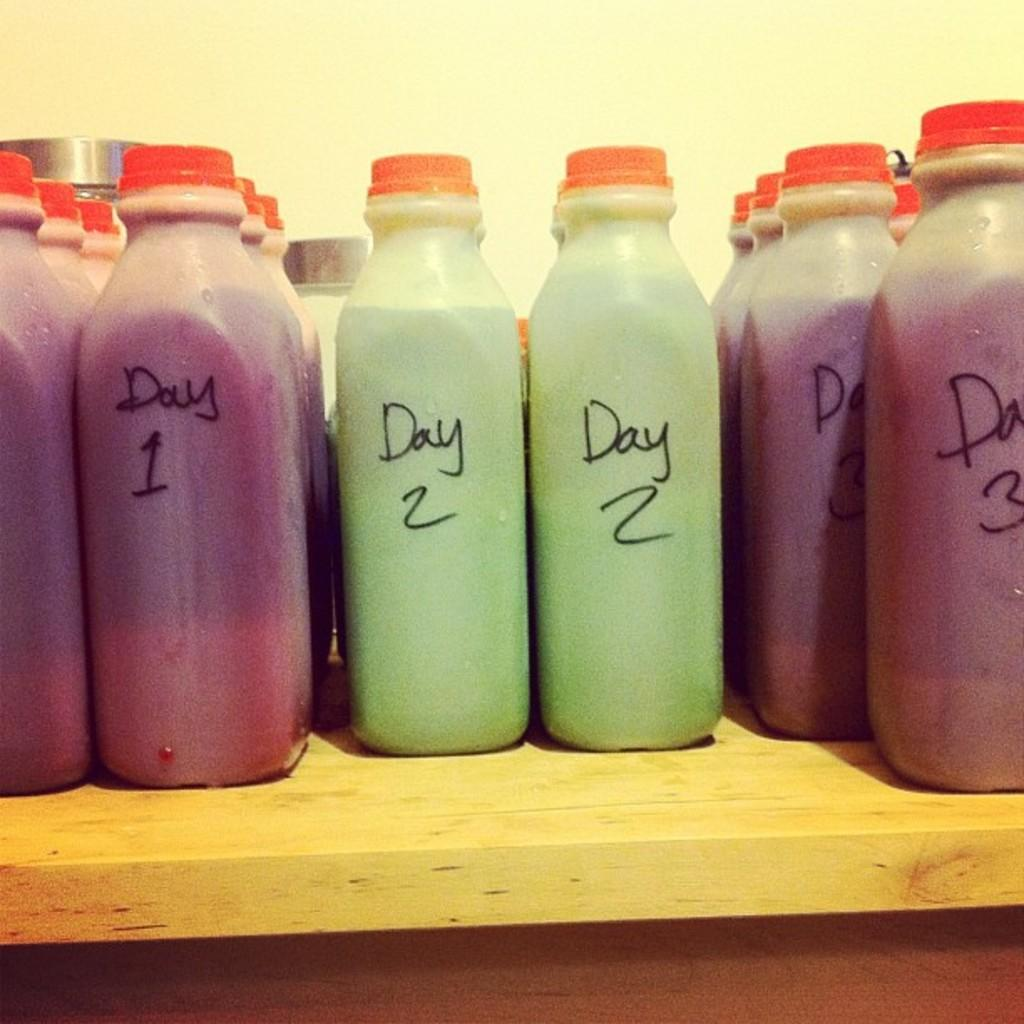<image>
Create a compact narrative representing the image presented. Plastic bottles of purple and green stuff are labelled with numbered days. 